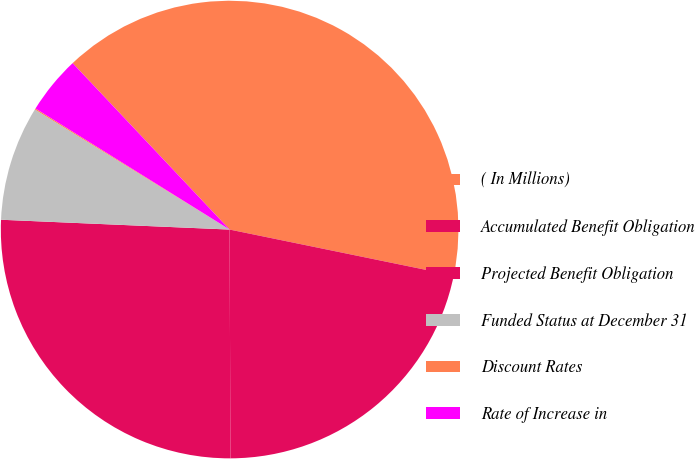Convert chart to OTSL. <chart><loc_0><loc_0><loc_500><loc_500><pie_chart><fcel>( In Millions)<fcel>Accumulated Benefit Obligation<fcel>Projected Benefit Obligation<fcel>Funded Status at December 31<fcel>Discount Rates<fcel>Rate of Increase in<nl><fcel>40.26%<fcel>21.72%<fcel>25.74%<fcel>8.11%<fcel>0.08%<fcel>4.09%<nl></chart> 